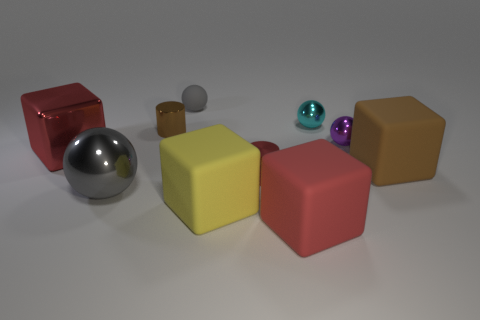Can you tell me the colors of the cubes present? Certainly, the colors of the cubes are red, yellow, beige, and two different shades of pink.  Which object is the largest? The largest object appears to be the yellow cube based on its dimensions relative to the other items. 